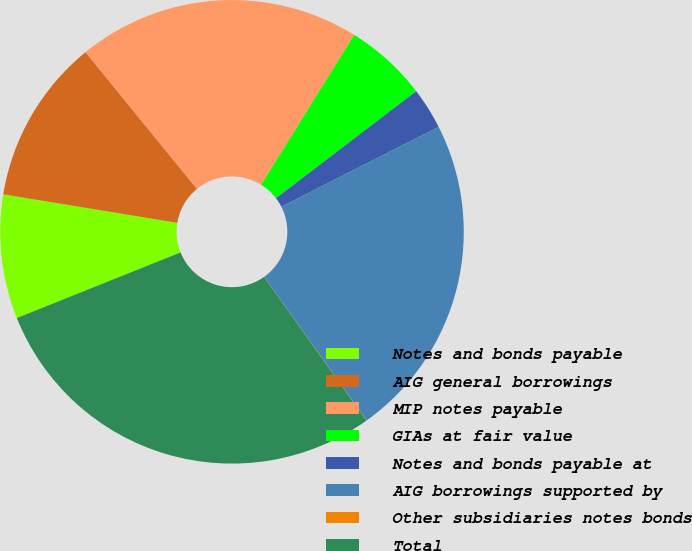Convert chart to OTSL. <chart><loc_0><loc_0><loc_500><loc_500><pie_chart><fcel>Notes and bonds payable<fcel>AIG general borrowings<fcel>MIP notes payable<fcel>GIAs at fair value<fcel>Notes and bonds payable at<fcel>AIG borrowings supported by<fcel>Other subsidiaries notes bonds<fcel>Total<nl><fcel>8.65%<fcel>11.53%<fcel>19.73%<fcel>5.78%<fcel>2.9%<fcel>22.6%<fcel>0.02%<fcel>28.79%<nl></chart> 